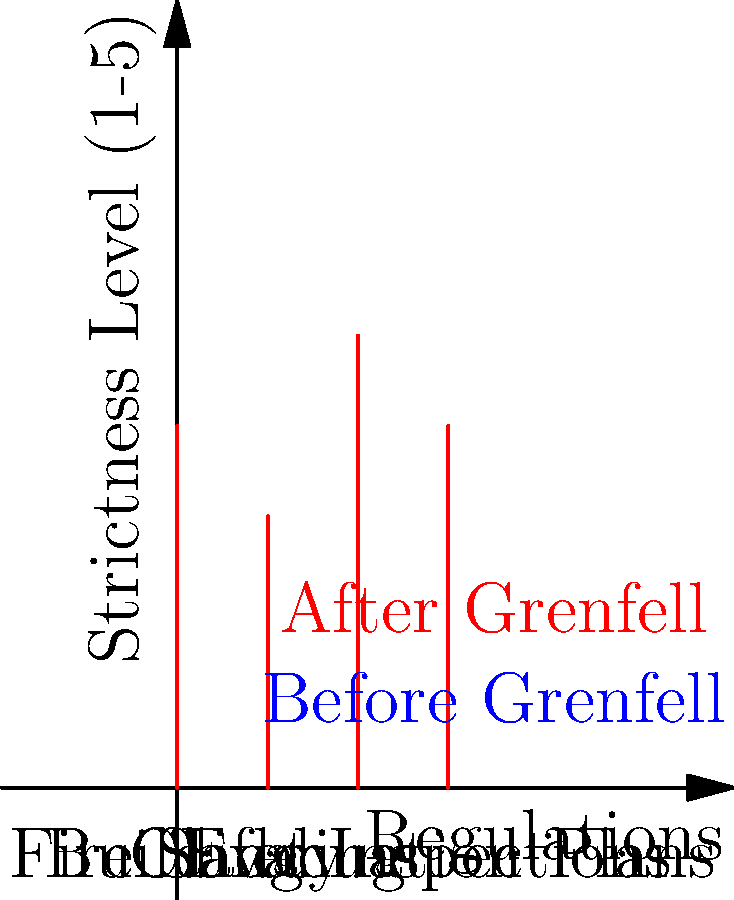According to the comparison infographic, which building safety regulation area showed the greatest increase in strictness level after the Grenfell Tower fire? To determine which building safety regulation area showed the greatest increase in strictness level, we need to:

1. Identify the four areas of regulation shown: Fire Safety, Cladding, Building Inspections, and Evacuation Plans.
2. Compare the "before" (blue) and "after" (red) levels for each area.
3. Calculate the increase for each area:
   a. Fire Safety: 4 - 2 = 2
   b. Cladding: 3 - 1 = 2
   c. Building Inspections: 5 - 3 = 2
   d. Evacuation Plans: 4 - 2 = 2
4. Identify the largest increase.

In this case, all areas show an equal increase of 2 levels. However, the question asks for the "greatest" increase, which can be interpreted as the highest final level.

5. Compare the final (after) levels:
   a. Fire Safety: 4
   b. Cladding: 3
   c. Building Inspections: 5
   d. Evacuation Plans: 4

The highest final level is 5, corresponding to Building Inspections.
Answer: Building Inspections 